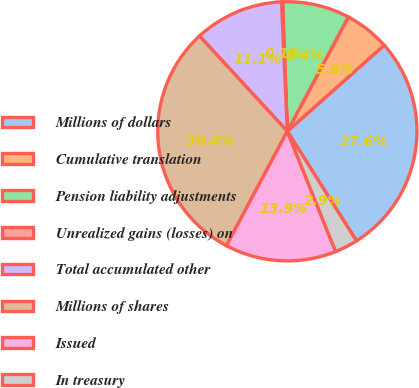Convert chart to OTSL. <chart><loc_0><loc_0><loc_500><loc_500><pie_chart><fcel>Millions of dollars<fcel>Cumulative translation<fcel>Pension liability adjustments<fcel>Unrealized gains (losses) on<fcel>Total accumulated other<fcel>Millions of shares<fcel>Issued<fcel>In treasury<nl><fcel>27.61%<fcel>5.63%<fcel>8.38%<fcel>0.14%<fcel>11.13%<fcel>30.36%<fcel>13.87%<fcel>2.88%<nl></chart> 